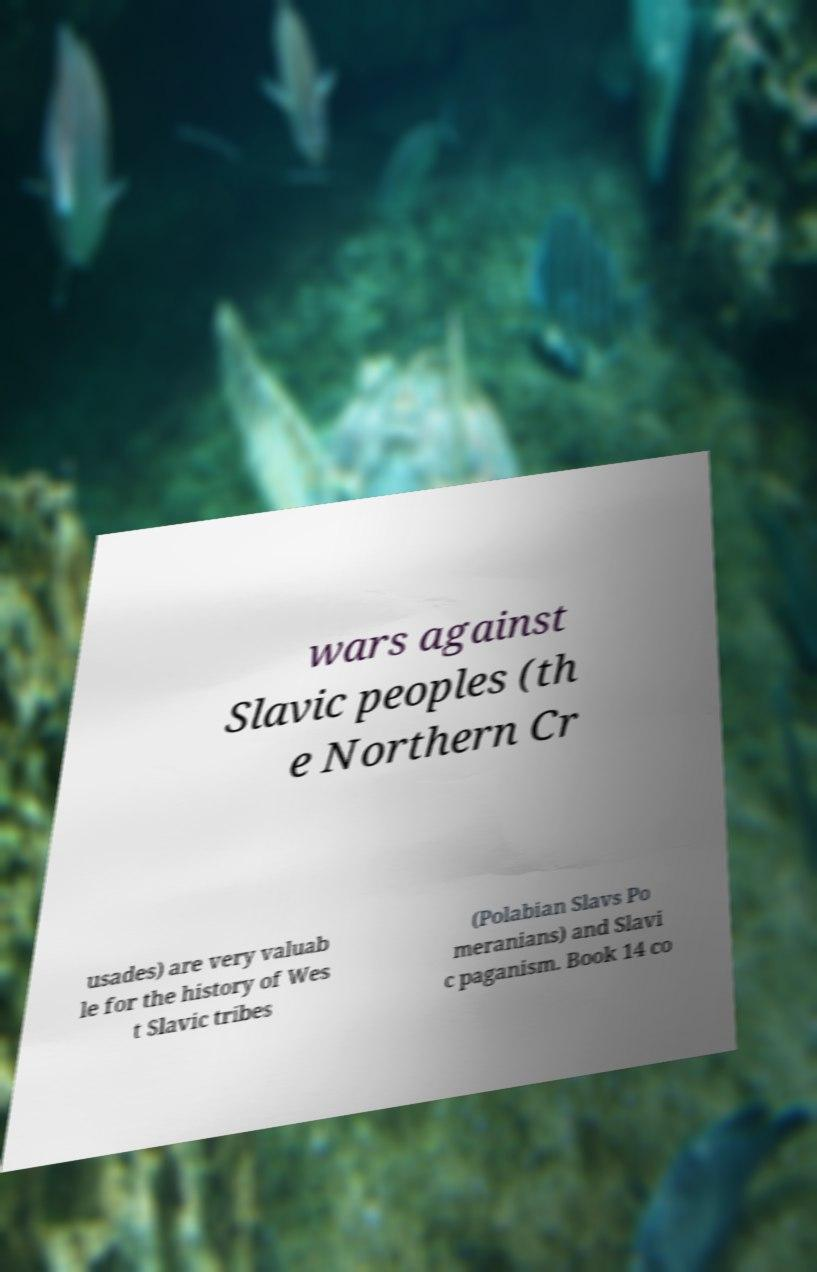Could you extract and type out the text from this image? wars against Slavic peoples (th e Northern Cr usades) are very valuab le for the history of Wes t Slavic tribes (Polabian Slavs Po meranians) and Slavi c paganism. Book 14 co 